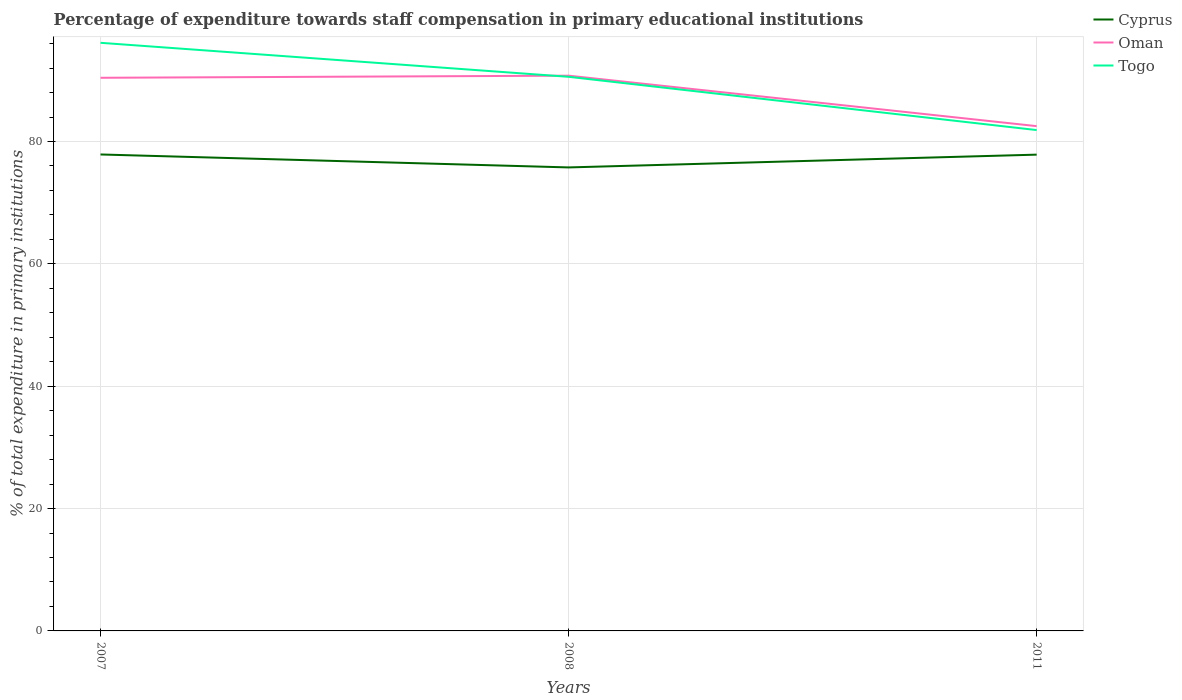How many different coloured lines are there?
Offer a very short reply. 3. Is the number of lines equal to the number of legend labels?
Provide a succinct answer. Yes. Across all years, what is the maximum percentage of expenditure towards staff compensation in Oman?
Provide a short and direct response. 82.51. In which year was the percentage of expenditure towards staff compensation in Cyprus maximum?
Your answer should be compact. 2008. What is the total percentage of expenditure towards staff compensation in Cyprus in the graph?
Offer a very short reply. 2.12. What is the difference between the highest and the second highest percentage of expenditure towards staff compensation in Oman?
Make the answer very short. 8.25. Is the percentage of expenditure towards staff compensation in Togo strictly greater than the percentage of expenditure towards staff compensation in Oman over the years?
Offer a terse response. No. How many lines are there?
Offer a terse response. 3. How many years are there in the graph?
Make the answer very short. 3. What is the difference between two consecutive major ticks on the Y-axis?
Ensure brevity in your answer.  20. Are the values on the major ticks of Y-axis written in scientific E-notation?
Provide a succinct answer. No. Does the graph contain grids?
Provide a succinct answer. Yes. How many legend labels are there?
Ensure brevity in your answer.  3. How are the legend labels stacked?
Keep it short and to the point. Vertical. What is the title of the graph?
Keep it short and to the point. Percentage of expenditure towards staff compensation in primary educational institutions. What is the label or title of the X-axis?
Provide a short and direct response. Years. What is the label or title of the Y-axis?
Your answer should be compact. % of total expenditure in primary institutions. What is the % of total expenditure in primary institutions of Cyprus in 2007?
Offer a very short reply. 77.88. What is the % of total expenditure in primary institutions in Oman in 2007?
Offer a terse response. 90.41. What is the % of total expenditure in primary institutions of Togo in 2007?
Offer a terse response. 96.13. What is the % of total expenditure in primary institutions of Cyprus in 2008?
Make the answer very short. 75.76. What is the % of total expenditure in primary institutions of Oman in 2008?
Your response must be concise. 90.76. What is the % of total expenditure in primary institutions of Togo in 2008?
Keep it short and to the point. 90.57. What is the % of total expenditure in primary institutions in Cyprus in 2011?
Offer a terse response. 77.85. What is the % of total expenditure in primary institutions in Oman in 2011?
Your answer should be compact. 82.51. What is the % of total expenditure in primary institutions in Togo in 2011?
Make the answer very short. 81.87. Across all years, what is the maximum % of total expenditure in primary institutions of Cyprus?
Keep it short and to the point. 77.88. Across all years, what is the maximum % of total expenditure in primary institutions in Oman?
Keep it short and to the point. 90.76. Across all years, what is the maximum % of total expenditure in primary institutions of Togo?
Your answer should be compact. 96.13. Across all years, what is the minimum % of total expenditure in primary institutions in Cyprus?
Offer a very short reply. 75.76. Across all years, what is the minimum % of total expenditure in primary institutions in Oman?
Provide a succinct answer. 82.51. Across all years, what is the minimum % of total expenditure in primary institutions of Togo?
Give a very brief answer. 81.87. What is the total % of total expenditure in primary institutions of Cyprus in the graph?
Make the answer very short. 231.49. What is the total % of total expenditure in primary institutions in Oman in the graph?
Keep it short and to the point. 263.68. What is the total % of total expenditure in primary institutions in Togo in the graph?
Make the answer very short. 268.57. What is the difference between the % of total expenditure in primary institutions of Cyprus in 2007 and that in 2008?
Provide a short and direct response. 2.12. What is the difference between the % of total expenditure in primary institutions of Oman in 2007 and that in 2008?
Make the answer very short. -0.34. What is the difference between the % of total expenditure in primary institutions in Togo in 2007 and that in 2008?
Make the answer very short. 5.56. What is the difference between the % of total expenditure in primary institutions of Cyprus in 2007 and that in 2011?
Your answer should be compact. 0.03. What is the difference between the % of total expenditure in primary institutions of Oman in 2007 and that in 2011?
Your answer should be compact. 7.9. What is the difference between the % of total expenditure in primary institutions in Togo in 2007 and that in 2011?
Give a very brief answer. 14.26. What is the difference between the % of total expenditure in primary institutions in Cyprus in 2008 and that in 2011?
Provide a succinct answer. -2.09. What is the difference between the % of total expenditure in primary institutions of Oman in 2008 and that in 2011?
Make the answer very short. 8.25. What is the difference between the % of total expenditure in primary institutions in Togo in 2008 and that in 2011?
Your answer should be very brief. 8.71. What is the difference between the % of total expenditure in primary institutions in Cyprus in 2007 and the % of total expenditure in primary institutions in Oman in 2008?
Give a very brief answer. -12.88. What is the difference between the % of total expenditure in primary institutions in Cyprus in 2007 and the % of total expenditure in primary institutions in Togo in 2008?
Offer a terse response. -12.7. What is the difference between the % of total expenditure in primary institutions in Oman in 2007 and the % of total expenditure in primary institutions in Togo in 2008?
Your answer should be compact. -0.16. What is the difference between the % of total expenditure in primary institutions in Cyprus in 2007 and the % of total expenditure in primary institutions in Oman in 2011?
Your response must be concise. -4.63. What is the difference between the % of total expenditure in primary institutions of Cyprus in 2007 and the % of total expenditure in primary institutions of Togo in 2011?
Your response must be concise. -3.99. What is the difference between the % of total expenditure in primary institutions in Oman in 2007 and the % of total expenditure in primary institutions in Togo in 2011?
Your response must be concise. 8.55. What is the difference between the % of total expenditure in primary institutions of Cyprus in 2008 and the % of total expenditure in primary institutions of Oman in 2011?
Provide a short and direct response. -6.75. What is the difference between the % of total expenditure in primary institutions in Cyprus in 2008 and the % of total expenditure in primary institutions in Togo in 2011?
Your answer should be compact. -6.11. What is the difference between the % of total expenditure in primary institutions of Oman in 2008 and the % of total expenditure in primary institutions of Togo in 2011?
Your answer should be very brief. 8.89. What is the average % of total expenditure in primary institutions in Cyprus per year?
Ensure brevity in your answer.  77.16. What is the average % of total expenditure in primary institutions of Oman per year?
Provide a short and direct response. 87.89. What is the average % of total expenditure in primary institutions in Togo per year?
Provide a succinct answer. 89.52. In the year 2007, what is the difference between the % of total expenditure in primary institutions of Cyprus and % of total expenditure in primary institutions of Oman?
Ensure brevity in your answer.  -12.54. In the year 2007, what is the difference between the % of total expenditure in primary institutions of Cyprus and % of total expenditure in primary institutions of Togo?
Your response must be concise. -18.25. In the year 2007, what is the difference between the % of total expenditure in primary institutions of Oman and % of total expenditure in primary institutions of Togo?
Your answer should be compact. -5.72. In the year 2008, what is the difference between the % of total expenditure in primary institutions of Cyprus and % of total expenditure in primary institutions of Oman?
Offer a terse response. -15. In the year 2008, what is the difference between the % of total expenditure in primary institutions in Cyprus and % of total expenditure in primary institutions in Togo?
Offer a terse response. -14.81. In the year 2008, what is the difference between the % of total expenditure in primary institutions in Oman and % of total expenditure in primary institutions in Togo?
Your response must be concise. 0.18. In the year 2011, what is the difference between the % of total expenditure in primary institutions in Cyprus and % of total expenditure in primary institutions in Oman?
Your response must be concise. -4.66. In the year 2011, what is the difference between the % of total expenditure in primary institutions of Cyprus and % of total expenditure in primary institutions of Togo?
Your answer should be very brief. -4.02. In the year 2011, what is the difference between the % of total expenditure in primary institutions in Oman and % of total expenditure in primary institutions in Togo?
Ensure brevity in your answer.  0.64. What is the ratio of the % of total expenditure in primary institutions of Cyprus in 2007 to that in 2008?
Ensure brevity in your answer.  1.03. What is the ratio of the % of total expenditure in primary institutions of Togo in 2007 to that in 2008?
Keep it short and to the point. 1.06. What is the ratio of the % of total expenditure in primary institutions in Oman in 2007 to that in 2011?
Provide a succinct answer. 1.1. What is the ratio of the % of total expenditure in primary institutions in Togo in 2007 to that in 2011?
Your response must be concise. 1.17. What is the ratio of the % of total expenditure in primary institutions of Cyprus in 2008 to that in 2011?
Your answer should be compact. 0.97. What is the ratio of the % of total expenditure in primary institutions of Oman in 2008 to that in 2011?
Keep it short and to the point. 1.1. What is the ratio of the % of total expenditure in primary institutions of Togo in 2008 to that in 2011?
Offer a terse response. 1.11. What is the difference between the highest and the second highest % of total expenditure in primary institutions of Cyprus?
Your response must be concise. 0.03. What is the difference between the highest and the second highest % of total expenditure in primary institutions of Oman?
Provide a succinct answer. 0.34. What is the difference between the highest and the second highest % of total expenditure in primary institutions of Togo?
Offer a terse response. 5.56. What is the difference between the highest and the lowest % of total expenditure in primary institutions of Cyprus?
Make the answer very short. 2.12. What is the difference between the highest and the lowest % of total expenditure in primary institutions of Oman?
Keep it short and to the point. 8.25. What is the difference between the highest and the lowest % of total expenditure in primary institutions of Togo?
Ensure brevity in your answer.  14.26. 